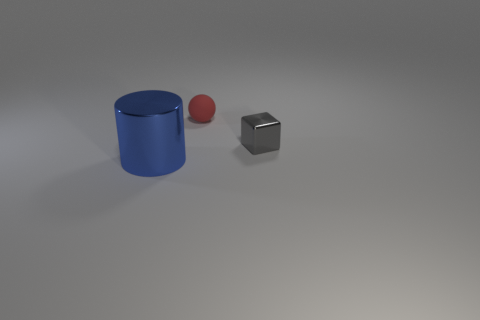Add 3 small gray shiny objects. How many objects exist? 6 Subtract all cubes. How many objects are left? 2 Subtract 1 gray cubes. How many objects are left? 2 Subtract all large shiny things. Subtract all shiny cylinders. How many objects are left? 1 Add 1 blue shiny cylinders. How many blue shiny cylinders are left? 2 Add 1 green matte things. How many green matte things exist? 1 